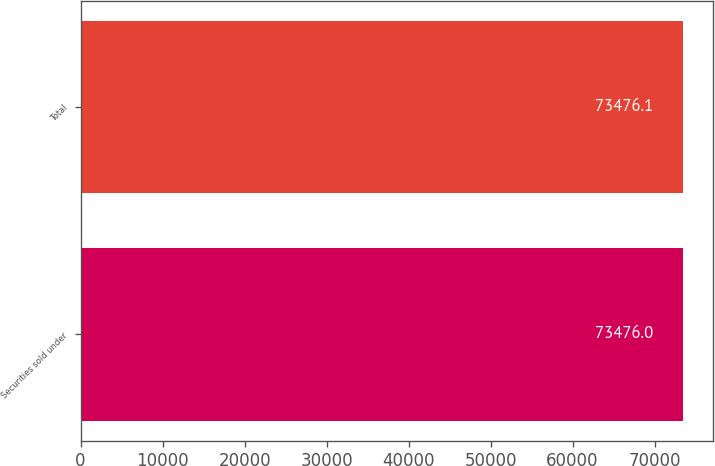Convert chart. <chart><loc_0><loc_0><loc_500><loc_500><bar_chart><fcel>Securities sold under<fcel>Total<nl><fcel>73476<fcel>73476.1<nl></chart> 